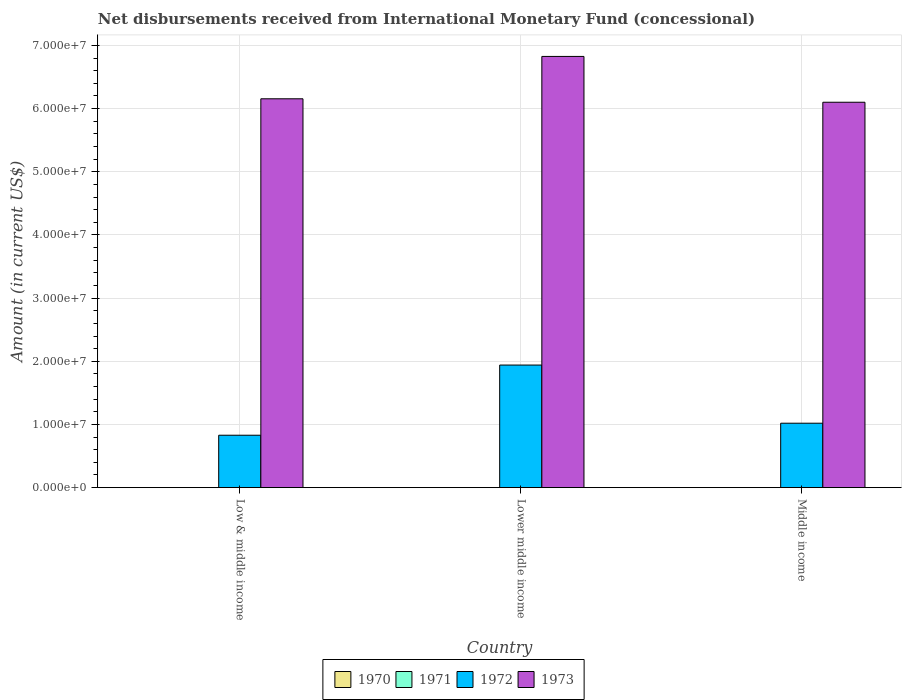How many different coloured bars are there?
Your answer should be very brief. 2. How many groups of bars are there?
Offer a terse response. 3. Are the number of bars per tick equal to the number of legend labels?
Your response must be concise. No. How many bars are there on the 3rd tick from the left?
Your answer should be compact. 2. What is the label of the 2nd group of bars from the left?
Provide a short and direct response. Lower middle income. In how many cases, is the number of bars for a given country not equal to the number of legend labels?
Provide a succinct answer. 3. What is the amount of disbursements received from International Monetary Fund in 1970 in Lower middle income?
Your answer should be very brief. 0. Across all countries, what is the maximum amount of disbursements received from International Monetary Fund in 1972?
Offer a very short reply. 1.94e+07. Across all countries, what is the minimum amount of disbursements received from International Monetary Fund in 1971?
Make the answer very short. 0. In which country was the amount of disbursements received from International Monetary Fund in 1973 maximum?
Give a very brief answer. Lower middle income. What is the total amount of disbursements received from International Monetary Fund in 1972 in the graph?
Ensure brevity in your answer.  3.79e+07. What is the difference between the amount of disbursements received from International Monetary Fund in 1973 in Lower middle income and that in Middle income?
Your response must be concise. 7.25e+06. What is the difference between the amount of disbursements received from International Monetary Fund in 1972 in Low & middle income and the amount of disbursements received from International Monetary Fund in 1970 in Middle income?
Ensure brevity in your answer.  8.30e+06. What is the average amount of disbursements received from International Monetary Fund in 1971 per country?
Your response must be concise. 0. What is the difference between the amount of disbursements received from International Monetary Fund of/in 1972 and amount of disbursements received from International Monetary Fund of/in 1973 in Lower middle income?
Your answer should be compact. -4.89e+07. In how many countries, is the amount of disbursements received from International Monetary Fund in 1973 greater than 58000000 US$?
Ensure brevity in your answer.  3. What is the ratio of the amount of disbursements received from International Monetary Fund in 1972 in Low & middle income to that in Lower middle income?
Your response must be concise. 0.43. Is the amount of disbursements received from International Monetary Fund in 1973 in Low & middle income less than that in Middle income?
Give a very brief answer. No. Is the difference between the amount of disbursements received from International Monetary Fund in 1972 in Low & middle income and Middle income greater than the difference between the amount of disbursements received from International Monetary Fund in 1973 in Low & middle income and Middle income?
Give a very brief answer. No. What is the difference between the highest and the second highest amount of disbursements received from International Monetary Fund in 1972?
Keep it short and to the point. 9.21e+06. What is the difference between the highest and the lowest amount of disbursements received from International Monetary Fund in 1972?
Offer a terse response. 1.11e+07. In how many countries, is the amount of disbursements received from International Monetary Fund in 1970 greater than the average amount of disbursements received from International Monetary Fund in 1970 taken over all countries?
Make the answer very short. 0. Is the sum of the amount of disbursements received from International Monetary Fund in 1973 in Low & middle income and Middle income greater than the maximum amount of disbursements received from International Monetary Fund in 1971 across all countries?
Make the answer very short. Yes. What is the difference between two consecutive major ticks on the Y-axis?
Offer a very short reply. 1.00e+07. Does the graph contain any zero values?
Make the answer very short. Yes. How are the legend labels stacked?
Your answer should be compact. Horizontal. What is the title of the graph?
Ensure brevity in your answer.  Net disbursements received from International Monetary Fund (concessional). Does "1991" appear as one of the legend labels in the graph?
Your response must be concise. No. What is the label or title of the Y-axis?
Make the answer very short. Amount (in current US$). What is the Amount (in current US$) of 1971 in Low & middle income?
Offer a terse response. 0. What is the Amount (in current US$) of 1972 in Low & middle income?
Your answer should be compact. 8.30e+06. What is the Amount (in current US$) in 1973 in Low & middle income?
Keep it short and to the point. 6.16e+07. What is the Amount (in current US$) of 1971 in Lower middle income?
Provide a short and direct response. 0. What is the Amount (in current US$) of 1972 in Lower middle income?
Give a very brief answer. 1.94e+07. What is the Amount (in current US$) in 1973 in Lower middle income?
Your answer should be very brief. 6.83e+07. What is the Amount (in current US$) in 1970 in Middle income?
Your answer should be very brief. 0. What is the Amount (in current US$) in 1972 in Middle income?
Give a very brief answer. 1.02e+07. What is the Amount (in current US$) in 1973 in Middle income?
Your answer should be compact. 6.10e+07. Across all countries, what is the maximum Amount (in current US$) in 1972?
Your answer should be very brief. 1.94e+07. Across all countries, what is the maximum Amount (in current US$) in 1973?
Your answer should be very brief. 6.83e+07. Across all countries, what is the minimum Amount (in current US$) of 1972?
Your response must be concise. 8.30e+06. Across all countries, what is the minimum Amount (in current US$) of 1973?
Give a very brief answer. 6.10e+07. What is the total Amount (in current US$) of 1970 in the graph?
Offer a terse response. 0. What is the total Amount (in current US$) in 1972 in the graph?
Ensure brevity in your answer.  3.79e+07. What is the total Amount (in current US$) in 1973 in the graph?
Give a very brief answer. 1.91e+08. What is the difference between the Amount (in current US$) of 1972 in Low & middle income and that in Lower middle income?
Your response must be concise. -1.11e+07. What is the difference between the Amount (in current US$) of 1973 in Low & middle income and that in Lower middle income?
Make the answer very short. -6.70e+06. What is the difference between the Amount (in current US$) of 1972 in Low & middle income and that in Middle income?
Your response must be concise. -1.90e+06. What is the difference between the Amount (in current US$) of 1973 in Low & middle income and that in Middle income?
Offer a terse response. 5.46e+05. What is the difference between the Amount (in current US$) in 1972 in Lower middle income and that in Middle income?
Offer a very short reply. 9.21e+06. What is the difference between the Amount (in current US$) in 1973 in Lower middle income and that in Middle income?
Ensure brevity in your answer.  7.25e+06. What is the difference between the Amount (in current US$) in 1972 in Low & middle income and the Amount (in current US$) in 1973 in Lower middle income?
Make the answer very short. -6.00e+07. What is the difference between the Amount (in current US$) of 1972 in Low & middle income and the Amount (in current US$) of 1973 in Middle income?
Provide a short and direct response. -5.27e+07. What is the difference between the Amount (in current US$) in 1972 in Lower middle income and the Amount (in current US$) in 1973 in Middle income?
Give a very brief answer. -4.16e+07. What is the average Amount (in current US$) in 1970 per country?
Offer a very short reply. 0. What is the average Amount (in current US$) in 1972 per country?
Offer a terse response. 1.26e+07. What is the average Amount (in current US$) of 1973 per country?
Your answer should be very brief. 6.36e+07. What is the difference between the Amount (in current US$) in 1972 and Amount (in current US$) in 1973 in Low & middle income?
Offer a very short reply. -5.33e+07. What is the difference between the Amount (in current US$) in 1972 and Amount (in current US$) in 1973 in Lower middle income?
Give a very brief answer. -4.89e+07. What is the difference between the Amount (in current US$) in 1972 and Amount (in current US$) in 1973 in Middle income?
Your response must be concise. -5.08e+07. What is the ratio of the Amount (in current US$) in 1972 in Low & middle income to that in Lower middle income?
Offer a terse response. 0.43. What is the ratio of the Amount (in current US$) in 1973 in Low & middle income to that in Lower middle income?
Provide a short and direct response. 0.9. What is the ratio of the Amount (in current US$) in 1972 in Low & middle income to that in Middle income?
Make the answer very short. 0.81. What is the ratio of the Amount (in current US$) in 1973 in Low & middle income to that in Middle income?
Offer a very short reply. 1.01. What is the ratio of the Amount (in current US$) in 1972 in Lower middle income to that in Middle income?
Ensure brevity in your answer.  1.9. What is the ratio of the Amount (in current US$) of 1973 in Lower middle income to that in Middle income?
Keep it short and to the point. 1.12. What is the difference between the highest and the second highest Amount (in current US$) of 1972?
Keep it short and to the point. 9.21e+06. What is the difference between the highest and the second highest Amount (in current US$) of 1973?
Your answer should be compact. 6.70e+06. What is the difference between the highest and the lowest Amount (in current US$) of 1972?
Ensure brevity in your answer.  1.11e+07. What is the difference between the highest and the lowest Amount (in current US$) of 1973?
Provide a succinct answer. 7.25e+06. 